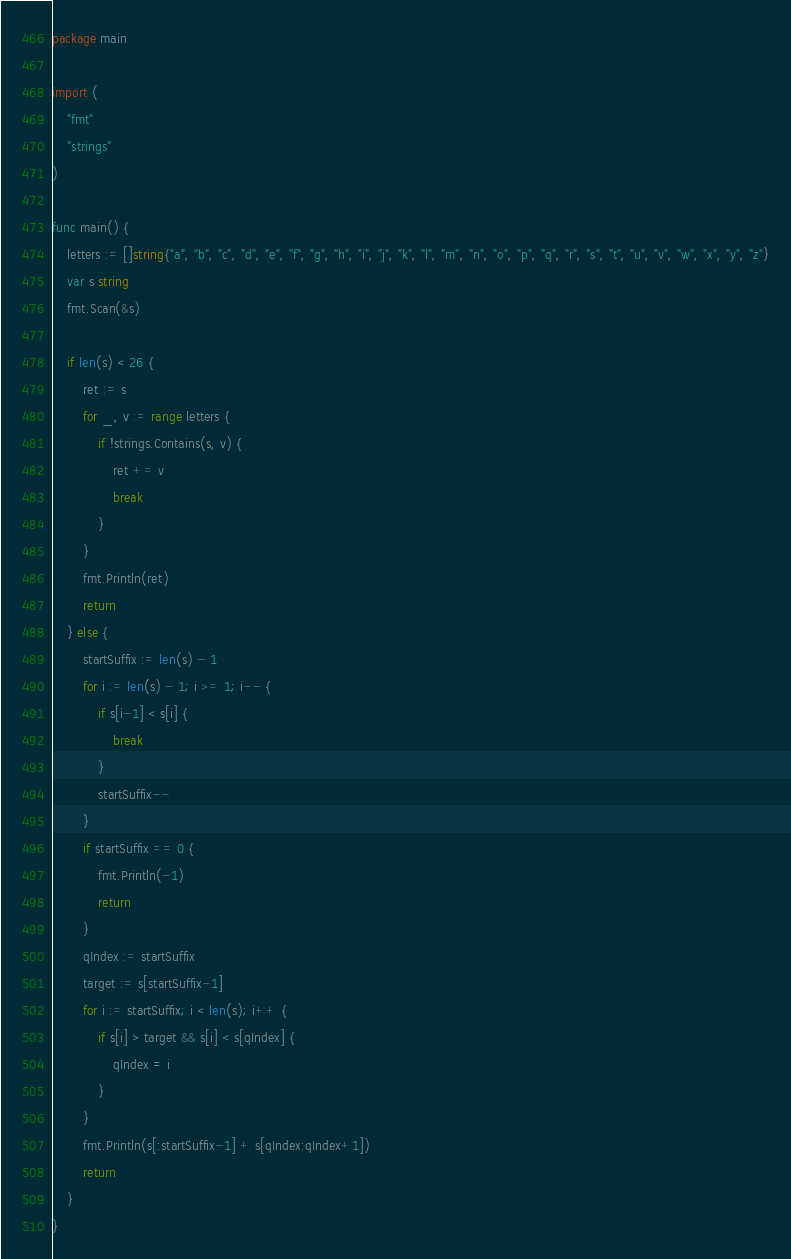Convert code to text. <code><loc_0><loc_0><loc_500><loc_500><_Go_>package main

import (
	"fmt"
	"strings"
)

func main() {
	letters := []string{"a", "b", "c", "d", "e", "f", "g", "h", "i", "j", "k", "l", "m", "n", "o", "p", "q", "r", "s", "t", "u", "v", "w", "x", "y", "z"}
	var s string
	fmt.Scan(&s)

	if len(s) < 26 {
		ret := s
		for _, v := range letters {
			if !strings.Contains(s, v) {
				ret += v
				break
			}
		}
		fmt.Println(ret)
		return
	} else {
		startSuffix := len(s) - 1
		for i := len(s) - 1; i >= 1; i-- {
			if s[i-1] < s[i] {
				break
			}
			startSuffix--
		}
		if startSuffix == 0 {
			fmt.Println(-1)
			return
		}
		qIndex := startSuffix
		target := s[startSuffix-1]
		for i := startSuffix; i < len(s); i++ {
			if s[i] > target && s[i] < s[qIndex] {
				qIndex = i
			}
		}
		fmt.Println(s[:startSuffix-1] + s[qIndex:qIndex+1])
		return
	}
}
</code> 